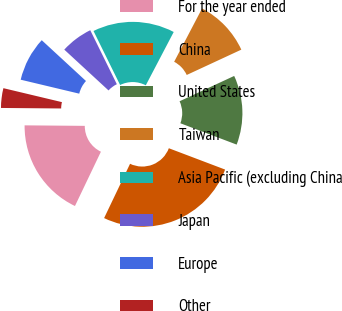Convert chart to OTSL. <chart><loc_0><loc_0><loc_500><loc_500><pie_chart><fcel>For the year ended<fcel>China<fcel>United States<fcel>Taiwan<fcel>Asia Pacific (excluding China<fcel>Japan<fcel>Europe<fcel>Other<nl><fcel>18.04%<fcel>26.33%<fcel>12.68%<fcel>10.41%<fcel>14.96%<fcel>5.86%<fcel>8.13%<fcel>3.59%<nl></chart> 